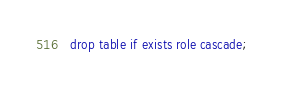<code> <loc_0><loc_0><loc_500><loc_500><_SQL_>drop table if exists role cascade;
</code> 